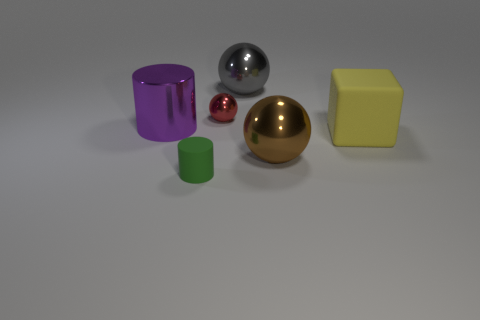Add 2 big gray things. How many objects exist? 8 Subtract all cylinders. How many objects are left? 4 Add 2 yellow rubber blocks. How many yellow rubber blocks are left? 3 Add 6 large objects. How many large objects exist? 10 Subtract 1 red spheres. How many objects are left? 5 Subtract all big purple shiny cylinders. Subtract all small matte cylinders. How many objects are left? 4 